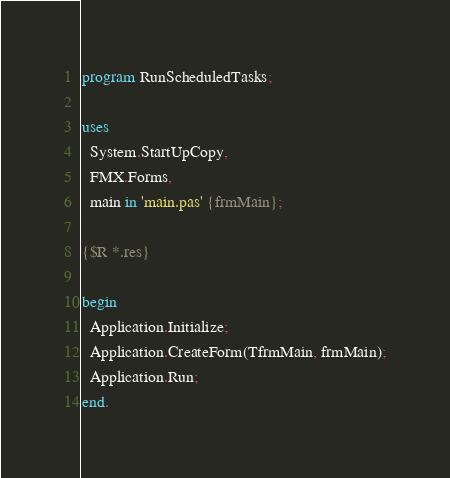Convert code to text. <code><loc_0><loc_0><loc_500><loc_500><_Pascal_>program RunScheduledTasks;

uses
  System.StartUpCopy,
  FMX.Forms,
  main in 'main.pas' {frmMain};

{$R *.res}

begin
  Application.Initialize;
  Application.CreateForm(TfrmMain, frmMain);
  Application.Run;
end.
</code> 